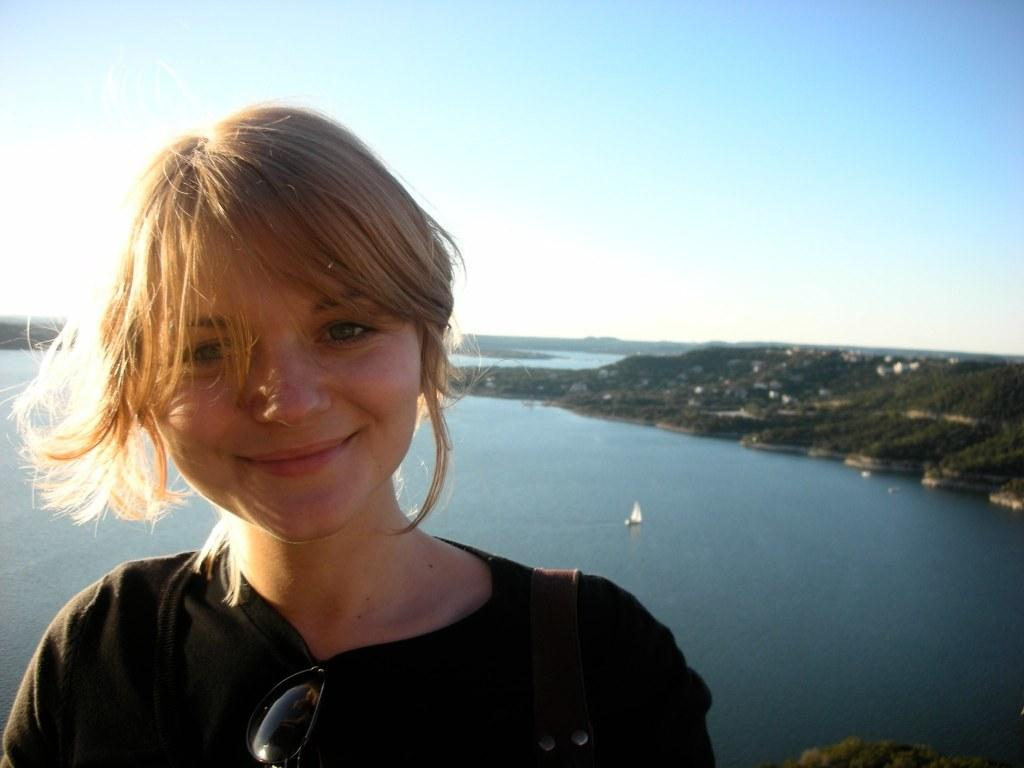What is the main subject of the image? There is a woman standing in the image. What is the woman's expression? The woman is smiling. What can be seen in the background of the image? There are mountains visible in the background of the image. What is the water in the image used for? The water is used for boating, as there is a boat on the water. What is visible at the top of the image? The sky is visible at the top of the image. What type of branch can be seen growing from the woman's head in the image? There is no branch growing from the woman's head in the image. What is the middle of the image used for? The middle of the image is not a specific location or object that serves a particular purpose; it is simply a part of the image that contains the woman, mountains, water, and boat. 